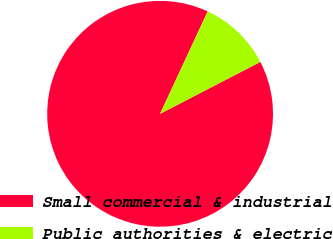Convert chart to OTSL. <chart><loc_0><loc_0><loc_500><loc_500><pie_chart><fcel>Small commercial & industrial<fcel>Public authorities & electric<nl><fcel>89.53%<fcel>10.47%<nl></chart> 